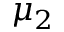Convert formula to latex. <formula><loc_0><loc_0><loc_500><loc_500>\mu _ { 2 }</formula> 